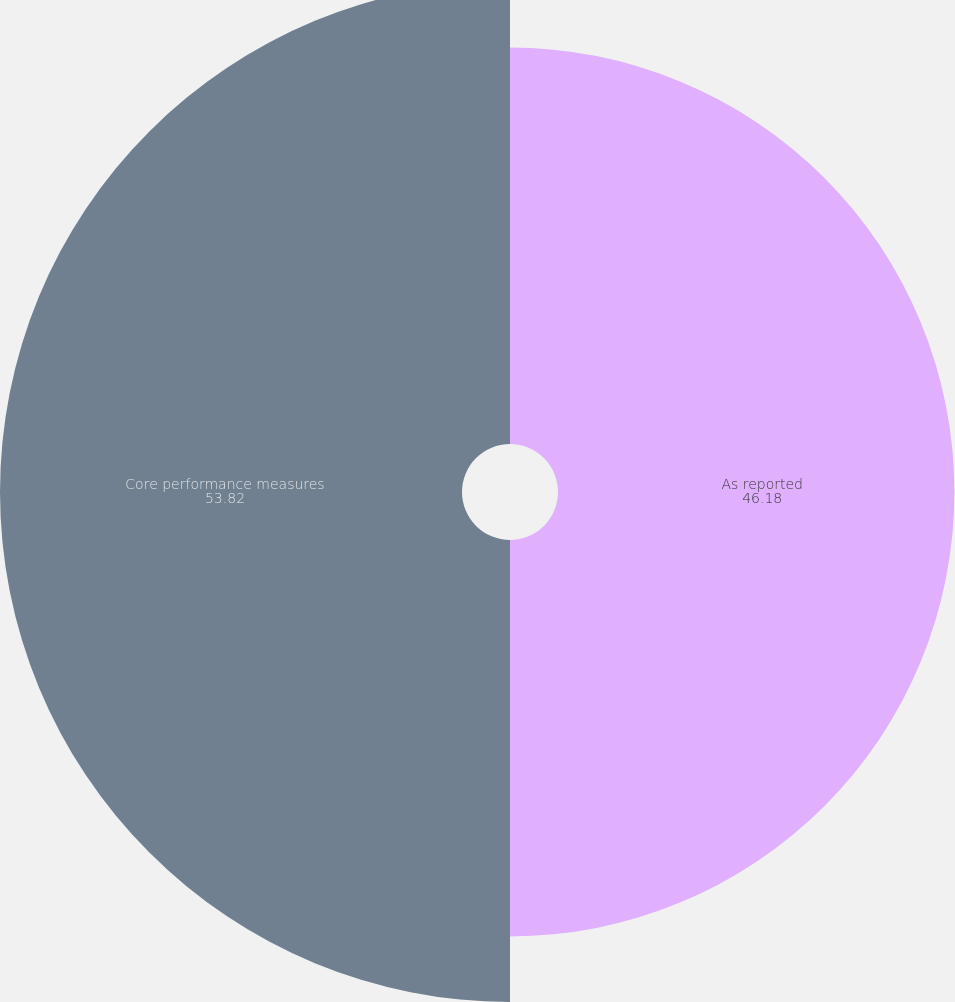<chart> <loc_0><loc_0><loc_500><loc_500><pie_chart><fcel>As reported<fcel>Core performance measures<nl><fcel>46.18%<fcel>53.82%<nl></chart> 